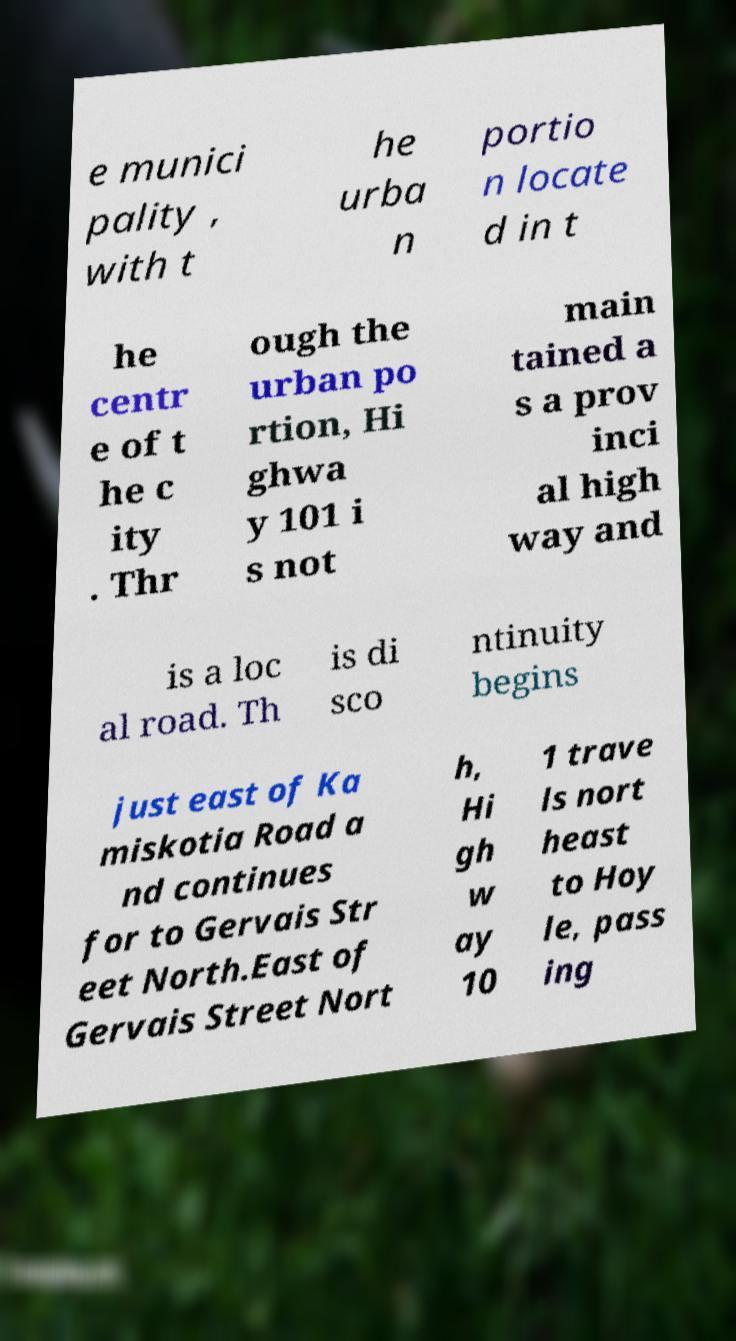Could you assist in decoding the text presented in this image and type it out clearly? e munici pality , with t he urba n portio n locate d in t he centr e of t he c ity . Thr ough the urban po rtion, Hi ghwa y 101 i s not main tained a s a prov inci al high way and is a loc al road. Th is di sco ntinuity begins just east of Ka miskotia Road a nd continues for to Gervais Str eet North.East of Gervais Street Nort h, Hi gh w ay 10 1 trave ls nort heast to Hoy le, pass ing 